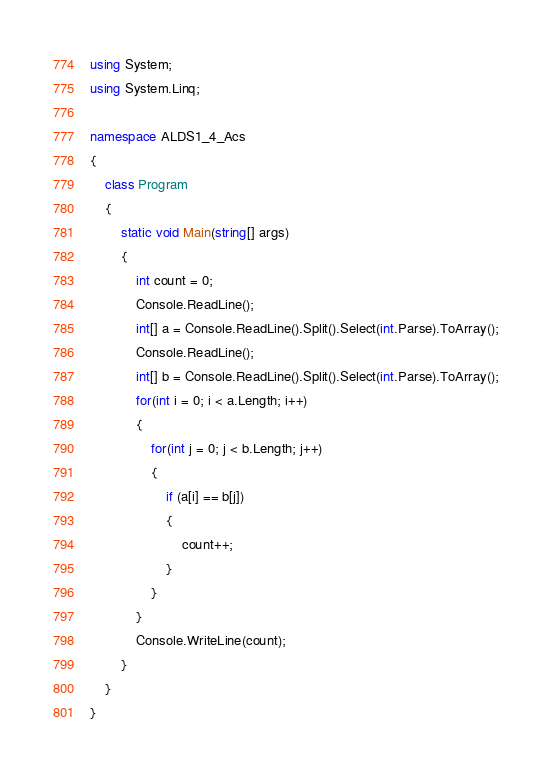Convert code to text. <code><loc_0><loc_0><loc_500><loc_500><_C#_>using System;
using System.Linq;

namespace ALDS1_4_Acs
{
    class Program
    {
        static void Main(string[] args)
        {
            int count = 0;
            Console.ReadLine();
            int[] a = Console.ReadLine().Split().Select(int.Parse).ToArray();
            Console.ReadLine();
            int[] b = Console.ReadLine().Split().Select(int.Parse).ToArray();
            for(int i = 0; i < a.Length; i++)
            {
                for(int j = 0; j < b.Length; j++)
                {
                    if (a[i] == b[j])
                    {
                        count++;
                    }
                }
            }
            Console.WriteLine(count);
        }
    }
}</code> 